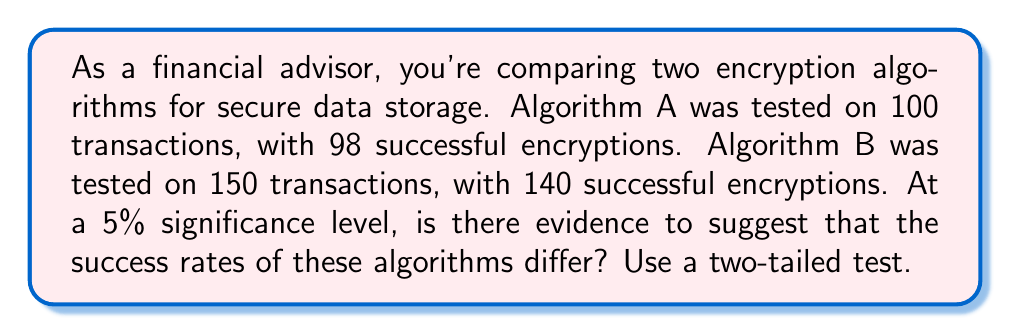What is the answer to this math problem? 1. Define hypotheses:
   $H_0: p_A = p_B$ (null hypothesis)
   $H_a: p_A \neq p_B$ (alternative hypothesis)

2. Calculate sample proportions:
   $\hat{p}_A = \frac{98}{100} = 0.98$
   $\hat{p}_B = \frac{140}{150} = \frac{14}{15} \approx 0.9333$

3. Calculate pooled proportion:
   $\hat{p} = \frac{98 + 140}{100 + 150} = \frac{238}{250} = 0.952$

4. Calculate test statistic:
   $$z = \frac{\hat{p}_A - \hat{p}_B}{\sqrt{\hat{p}(1-\hat{p})(\frac{1}{n_A} + \frac{1}{n_B})}}$$
   $$z = \frac{0.98 - 0.9333}{\sqrt{0.952(1-0.952)(\frac{1}{100} + \frac{1}{150})}} \approx 1.9245$$

5. Find critical value:
   For a two-tailed test at 5% significance, $z_{\alpha/2} = 1.96$

6. Compare test statistic to critical value:
   $|z| = 1.9245 < 1.96 = z_{\alpha/2}$

7. Calculate p-value:
   $p\text{-value} = 2 \times P(Z > 1.9245) \approx 0.0543$

8. Decision:
   Since $|z| < z_{\alpha/2}$ and $p\text{-value} > 0.05$, we fail to reject the null hypothesis.
Answer: Fail to reject $H_0$; insufficient evidence to conclude different success rates. 